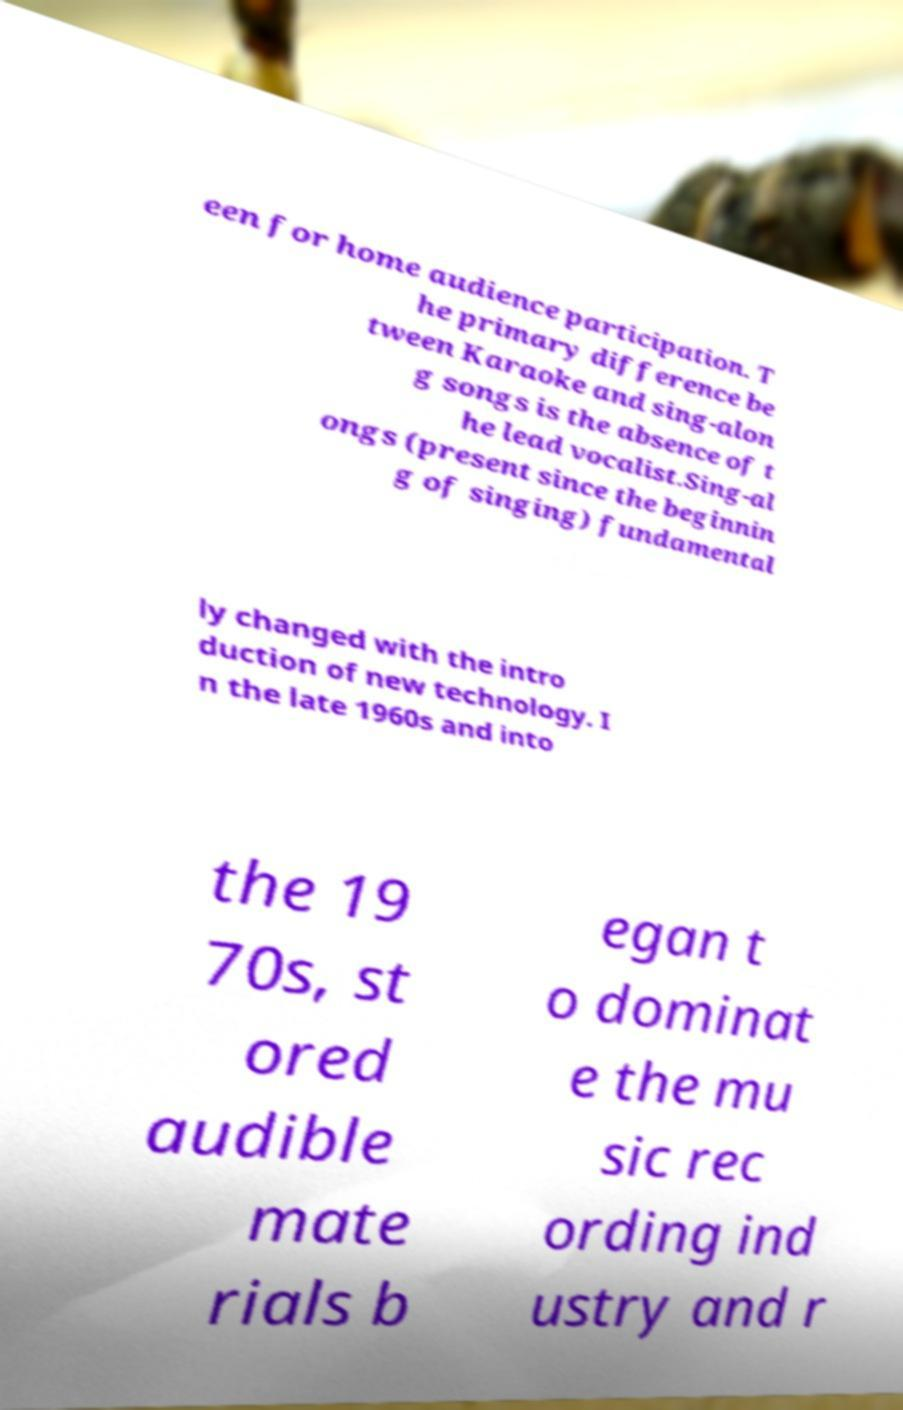Can you read and provide the text displayed in the image?This photo seems to have some interesting text. Can you extract and type it out for me? een for home audience participation. T he primary difference be tween Karaoke and sing-alon g songs is the absence of t he lead vocalist.Sing-al ongs (present since the beginnin g of singing) fundamental ly changed with the intro duction of new technology. I n the late 1960s and into the 19 70s, st ored audible mate rials b egan t o dominat e the mu sic rec ording ind ustry and r 